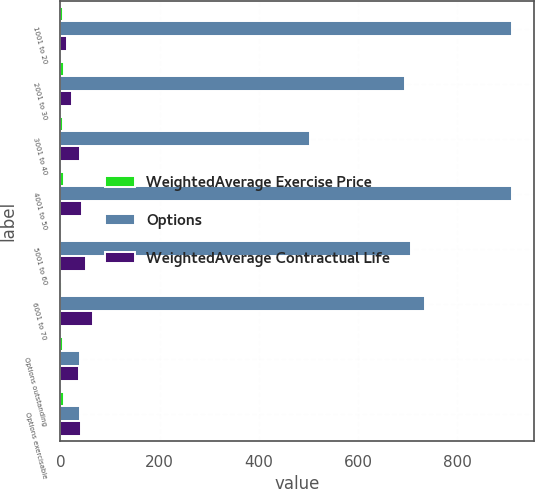<chart> <loc_0><loc_0><loc_500><loc_500><stacked_bar_chart><ecel><fcel>1001 to 20<fcel>2001 to 30<fcel>3001 to 40<fcel>4001 to 50<fcel>5001 to 60<fcel>6001 to 70<fcel>Options outstanding<fcel>Options exercisable<nl><fcel>WeightedAverage Exercise Price<fcel>6<fcel>6.9<fcel>4.7<fcel>8<fcel>1.6<fcel>2.5<fcel>5.1<fcel>7.6<nl><fcel>Options<fcel>910<fcel>695<fcel>503<fcel>910<fcel>706<fcel>736<fcel>38.5<fcel>38.5<nl><fcel>WeightedAverage Contractual Life<fcel>13<fcel>23<fcel>39<fcel>43<fcel>52<fcel>65<fcel>38<fcel>42<nl></chart> 